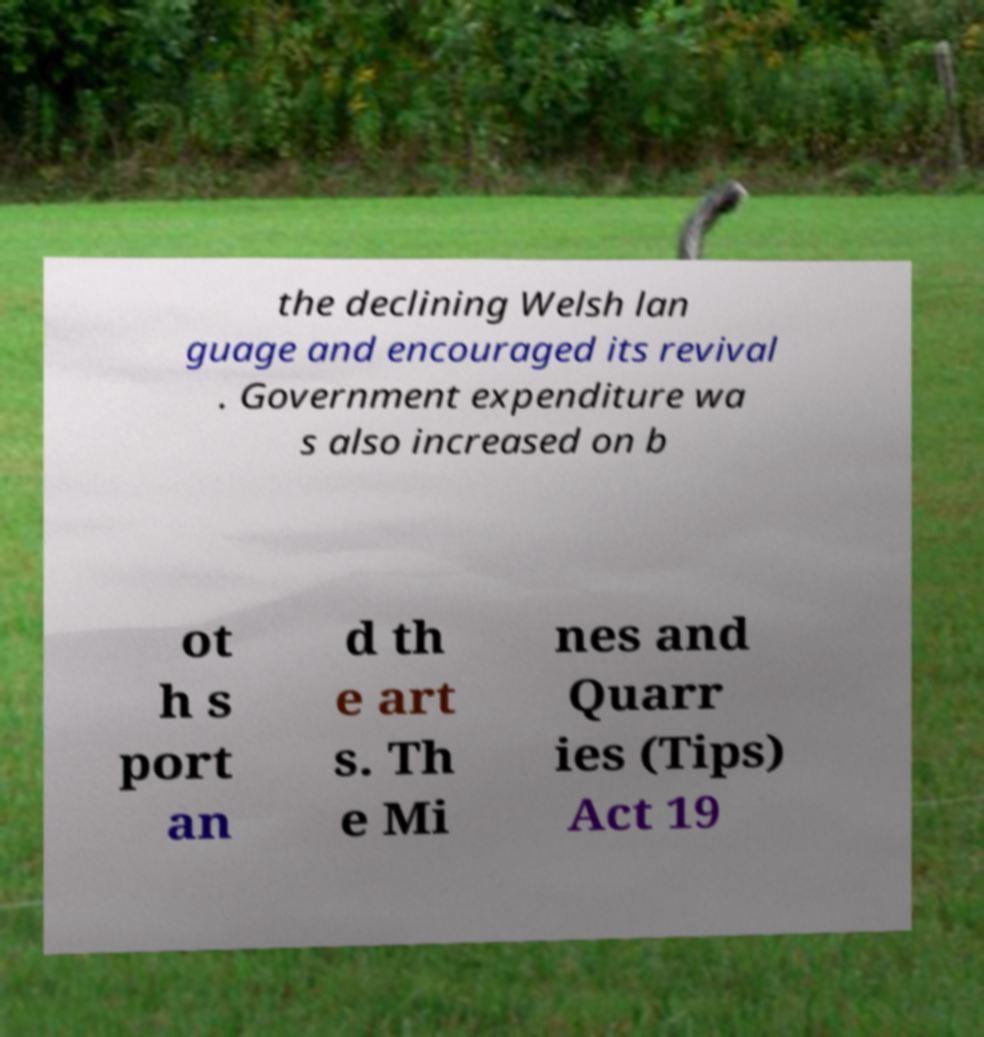Please identify and transcribe the text found in this image. the declining Welsh lan guage and encouraged its revival . Government expenditure wa s also increased on b ot h s port an d th e art s. Th e Mi nes and Quarr ies (Tips) Act 19 